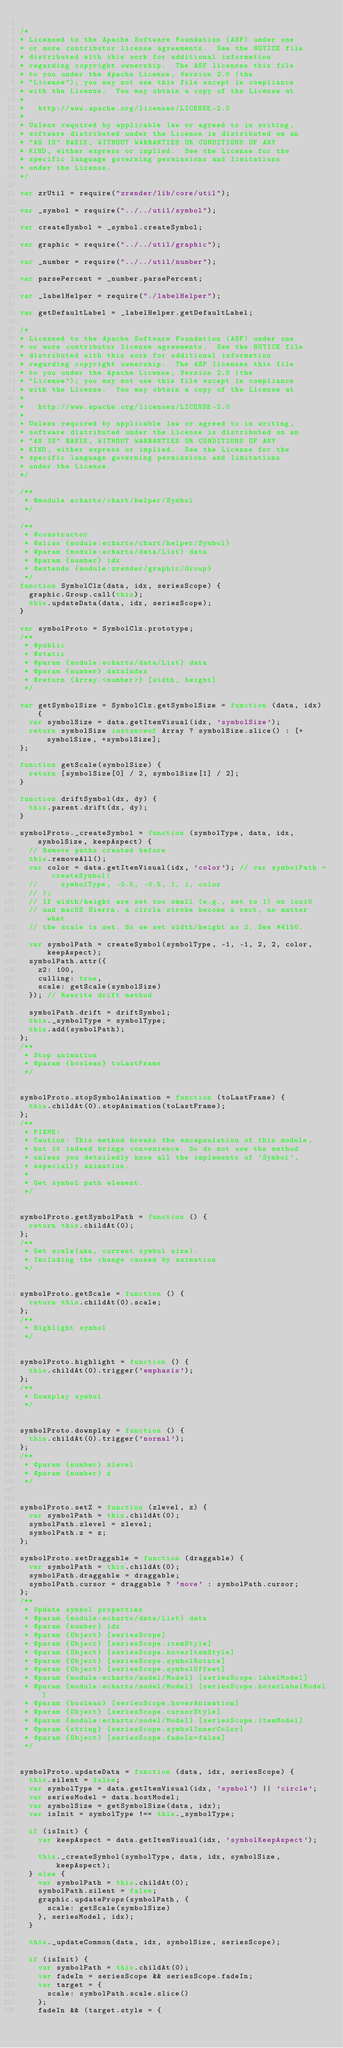<code> <loc_0><loc_0><loc_500><loc_500><_JavaScript_>
/*
* Licensed to the Apache Software Foundation (ASF) under one
* or more contributor license agreements.  See the NOTICE file
* distributed with this work for additional information
* regarding copyright ownership.  The ASF licenses this file
* to you under the Apache License, Version 2.0 (the
* "License"); you may not use this file except in compliance
* with the License.  You may obtain a copy of the License at
*
*   http://www.apache.org/licenses/LICENSE-2.0
*
* Unless required by applicable law or agreed to in writing,
* software distributed under the License is distributed on an
* "AS IS" BASIS, WITHOUT WARRANTIES OR CONDITIONS OF ANY
* KIND, either express or implied.  See the License for the
* specific language governing permissions and limitations
* under the License.
*/

var zrUtil = require("zrender/lib/core/util");

var _symbol = require("../../util/symbol");

var createSymbol = _symbol.createSymbol;

var graphic = require("../../util/graphic");

var _number = require("../../util/number");

var parsePercent = _number.parsePercent;

var _labelHelper = require("./labelHelper");

var getDefaultLabel = _labelHelper.getDefaultLabel;

/*
* Licensed to the Apache Software Foundation (ASF) under one
* or more contributor license agreements.  See the NOTICE file
* distributed with this work for additional information
* regarding copyright ownership.  The ASF licenses this file
* to you under the Apache License, Version 2.0 (the
* "License"); you may not use this file except in compliance
* with the License.  You may obtain a copy of the License at
*
*   http://www.apache.org/licenses/LICENSE-2.0
*
* Unless required by applicable law or agreed to in writing,
* software distributed under the License is distributed on an
* "AS IS" BASIS, WITHOUT WARRANTIES OR CONDITIONS OF ANY
* KIND, either express or implied.  See the License for the
* specific language governing permissions and limitations
* under the License.
*/

/**
 * @module echarts/chart/helper/Symbol
 */

/**
 * @constructor
 * @alias {module:echarts/chart/helper/Symbol}
 * @param {module:echarts/data/List} data
 * @param {number} idx
 * @extends {module:zrender/graphic/Group}
 */
function SymbolClz(data, idx, seriesScope) {
  graphic.Group.call(this);
  this.updateData(data, idx, seriesScope);
}

var symbolProto = SymbolClz.prototype;
/**
 * @public
 * @static
 * @param {module:echarts/data/List} data
 * @param {number} dataIndex
 * @return {Array.<number>} [width, height]
 */

var getSymbolSize = SymbolClz.getSymbolSize = function (data, idx) {
  var symbolSize = data.getItemVisual(idx, 'symbolSize');
  return symbolSize instanceof Array ? symbolSize.slice() : [+symbolSize, +symbolSize];
};

function getScale(symbolSize) {
  return [symbolSize[0] / 2, symbolSize[1] / 2];
}

function driftSymbol(dx, dy) {
  this.parent.drift(dx, dy);
}

symbolProto._createSymbol = function (symbolType, data, idx, symbolSize, keepAspect) {
  // Remove paths created before
  this.removeAll();
  var color = data.getItemVisual(idx, 'color'); // var symbolPath = createSymbol(
  //     symbolType, -0.5, -0.5, 1, 1, color
  // );
  // If width/height are set too small (e.g., set to 1) on ios10
  // and macOS Sierra, a circle stroke become a rect, no matter what
  // the scale is set. So we set width/height as 2. See #4150.

  var symbolPath = createSymbol(symbolType, -1, -1, 2, 2, color, keepAspect);
  symbolPath.attr({
    z2: 100,
    culling: true,
    scale: getScale(symbolSize)
  }); // Rewrite drift method

  symbolPath.drift = driftSymbol;
  this._symbolType = symbolType;
  this.add(symbolPath);
};
/**
 * Stop animation
 * @param {boolean} toLastFrame
 */


symbolProto.stopSymbolAnimation = function (toLastFrame) {
  this.childAt(0).stopAnimation(toLastFrame);
};
/**
 * FIXME:
 * Caution: This method breaks the encapsulation of this module,
 * but it indeed brings convenience. So do not use the method
 * unless you detailedly know all the implements of `Symbol`,
 * especially animation.
 *
 * Get symbol path element.
 */


symbolProto.getSymbolPath = function () {
  return this.childAt(0);
};
/**
 * Get scale(aka, current symbol size).
 * Including the change caused by animation
 */


symbolProto.getScale = function () {
  return this.childAt(0).scale;
};
/**
 * Highlight symbol
 */


symbolProto.highlight = function () {
  this.childAt(0).trigger('emphasis');
};
/**
 * Downplay symbol
 */


symbolProto.downplay = function () {
  this.childAt(0).trigger('normal');
};
/**
 * @param {number} zlevel
 * @param {number} z
 */


symbolProto.setZ = function (zlevel, z) {
  var symbolPath = this.childAt(0);
  symbolPath.zlevel = zlevel;
  symbolPath.z = z;
};

symbolProto.setDraggable = function (draggable) {
  var symbolPath = this.childAt(0);
  symbolPath.draggable = draggable;
  symbolPath.cursor = draggable ? 'move' : symbolPath.cursor;
};
/**
 * Update symbol properties
 * @param {module:echarts/data/List} data
 * @param {number} idx
 * @param {Object} [seriesScope]
 * @param {Object} [seriesScope.itemStyle]
 * @param {Object} [seriesScope.hoverItemStyle]
 * @param {Object} [seriesScope.symbolRotate]
 * @param {Object} [seriesScope.symbolOffset]
 * @param {module:echarts/model/Model} [seriesScope.labelModel]
 * @param {module:echarts/model/Model} [seriesScope.hoverLabelModel]
 * @param {boolean} [seriesScope.hoverAnimation]
 * @param {Object} [seriesScope.cursorStyle]
 * @param {module:echarts/model/Model} [seriesScope.itemModel]
 * @param {string} [seriesScope.symbolInnerColor]
 * @param {Object} [seriesScope.fadeIn=false]
 */


symbolProto.updateData = function (data, idx, seriesScope) {
  this.silent = false;
  var symbolType = data.getItemVisual(idx, 'symbol') || 'circle';
  var seriesModel = data.hostModel;
  var symbolSize = getSymbolSize(data, idx);
  var isInit = symbolType !== this._symbolType;

  if (isInit) {
    var keepAspect = data.getItemVisual(idx, 'symbolKeepAspect');

    this._createSymbol(symbolType, data, idx, symbolSize, keepAspect);
  } else {
    var symbolPath = this.childAt(0);
    symbolPath.silent = false;
    graphic.updateProps(symbolPath, {
      scale: getScale(symbolSize)
    }, seriesModel, idx);
  }

  this._updateCommon(data, idx, symbolSize, seriesScope);

  if (isInit) {
    var symbolPath = this.childAt(0);
    var fadeIn = seriesScope && seriesScope.fadeIn;
    var target = {
      scale: symbolPath.scale.slice()
    };
    fadeIn && (target.style = {</code> 